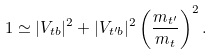<formula> <loc_0><loc_0><loc_500><loc_500>1 \simeq | V _ { t b } | ^ { 2 } + | V _ { t ^ { \prime } b } | ^ { 2 } \left ( \frac { m _ { t ^ { \prime } } } { m _ { t } } \right ) ^ { 2 } .</formula> 